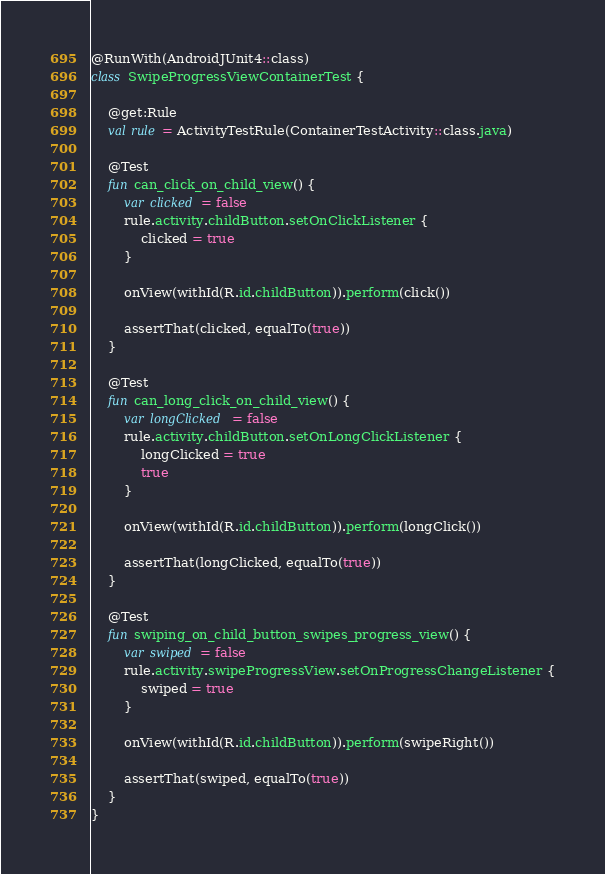<code> <loc_0><loc_0><loc_500><loc_500><_Kotlin_>
@RunWith(AndroidJUnit4::class)
class SwipeProgressViewContainerTest {

    @get:Rule
    val rule = ActivityTestRule(ContainerTestActivity::class.java)

    @Test
    fun can_click_on_child_view() {
        var clicked = false
        rule.activity.childButton.setOnClickListener {
            clicked = true
        }

        onView(withId(R.id.childButton)).perform(click())

        assertThat(clicked, equalTo(true))
    }

    @Test
    fun can_long_click_on_child_view() {
        var longClicked = false
        rule.activity.childButton.setOnLongClickListener {
            longClicked = true
            true
        }

        onView(withId(R.id.childButton)).perform(longClick())

        assertThat(longClicked, equalTo(true))
    }

    @Test
    fun swiping_on_child_button_swipes_progress_view() {
        var swiped = false
        rule.activity.swipeProgressView.setOnProgressChangeListener {
            swiped = true
        }

        onView(withId(R.id.childButton)).perform(swipeRight())

        assertThat(swiped, equalTo(true))
    }
}
</code> 